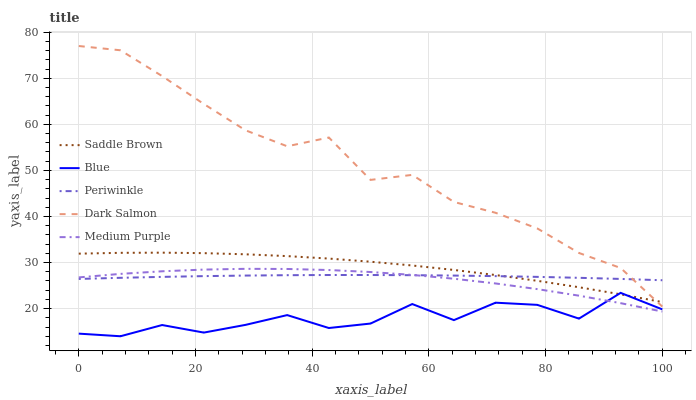Does Blue have the minimum area under the curve?
Answer yes or no. Yes. Does Dark Salmon have the maximum area under the curve?
Answer yes or no. Yes. Does Medium Purple have the minimum area under the curve?
Answer yes or no. No. Does Medium Purple have the maximum area under the curve?
Answer yes or no. No. Is Periwinkle the smoothest?
Answer yes or no. Yes. Is Blue the roughest?
Answer yes or no. Yes. Is Medium Purple the smoothest?
Answer yes or no. No. Is Medium Purple the roughest?
Answer yes or no. No. Does Blue have the lowest value?
Answer yes or no. Yes. Does Medium Purple have the lowest value?
Answer yes or no. No. Does Dark Salmon have the highest value?
Answer yes or no. Yes. Does Medium Purple have the highest value?
Answer yes or no. No. Is Blue less than Periwinkle?
Answer yes or no. Yes. Is Dark Salmon greater than Medium Purple?
Answer yes or no. Yes. Does Saddle Brown intersect Blue?
Answer yes or no. Yes. Is Saddle Brown less than Blue?
Answer yes or no. No. Is Saddle Brown greater than Blue?
Answer yes or no. No. Does Blue intersect Periwinkle?
Answer yes or no. No. 